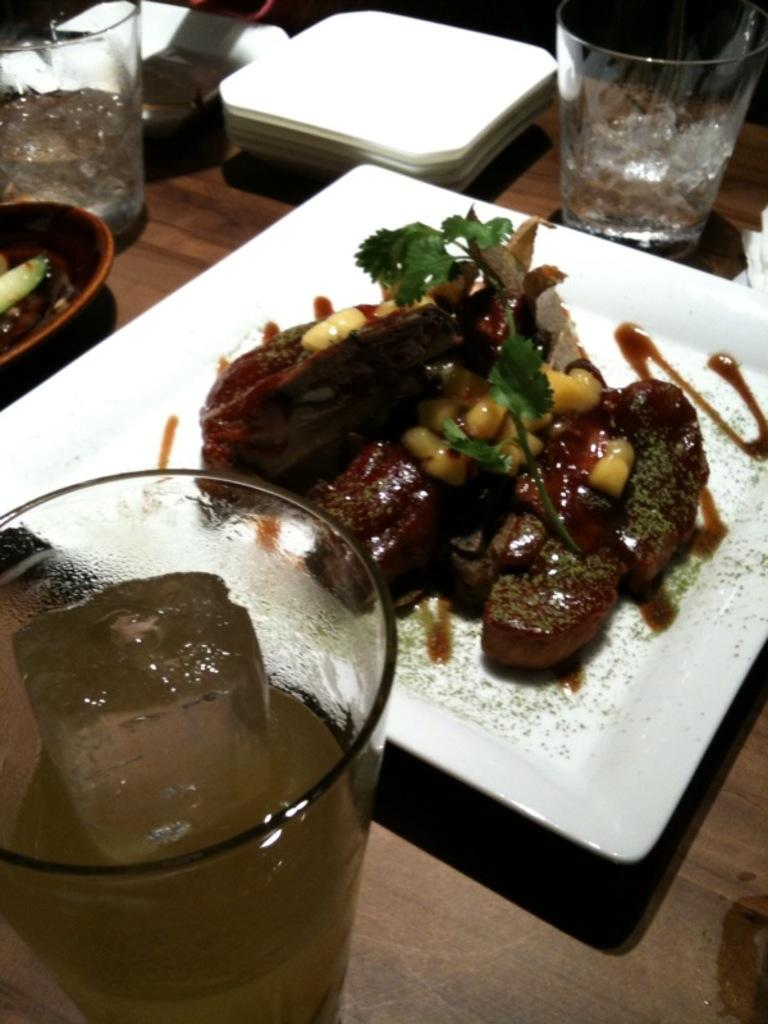What piece of furniture is present in the image? There is a table in the image. What objects are placed on the table? There are glasses, plates, a bowl, and a tray on the table. What is on the tray? There are food items on the tray. What type of prose can be heard being read by the committee at the harbor in the image? There is no mention of a committee, harbor, or prose in the image. The image only shows a table with various objects on it. 